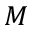Convert formula to latex. <formula><loc_0><loc_0><loc_500><loc_500>M</formula> 